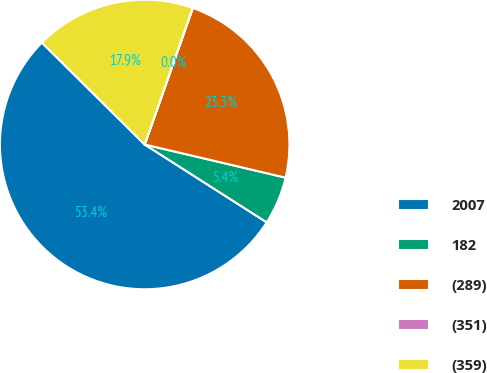Convert chart. <chart><loc_0><loc_0><loc_500><loc_500><pie_chart><fcel>2007<fcel>182<fcel>(289)<fcel>(351)<fcel>(359)<nl><fcel>53.39%<fcel>5.36%<fcel>23.28%<fcel>0.03%<fcel>17.94%<nl></chart> 